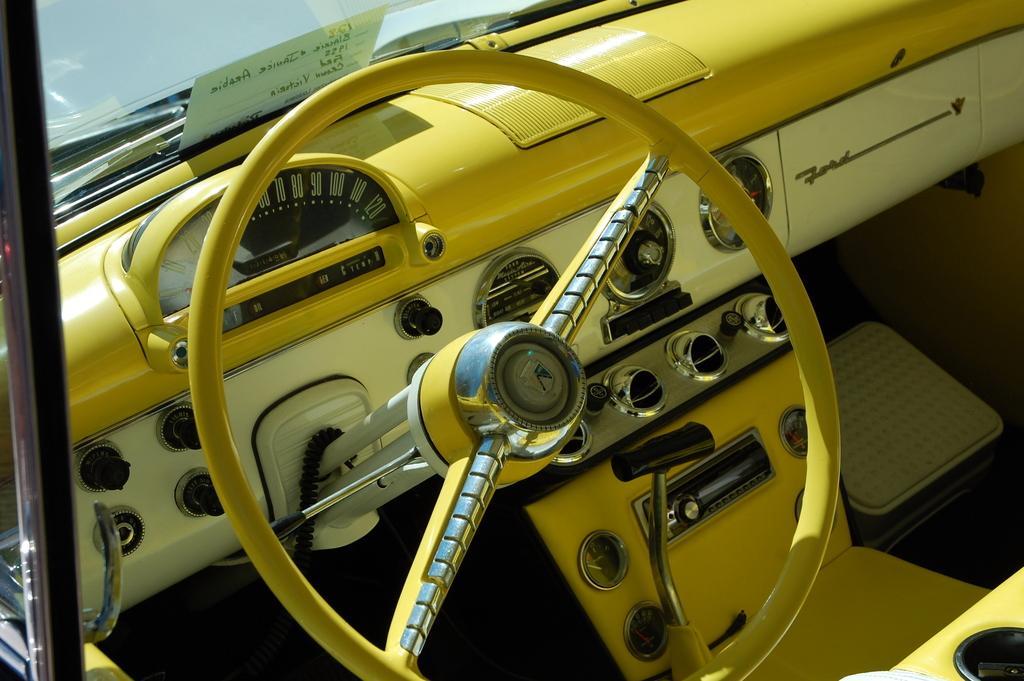Describe this image in one or two sentences. This picture shows a steering and dashboard of a vehicle. It is yellow and white in color. 